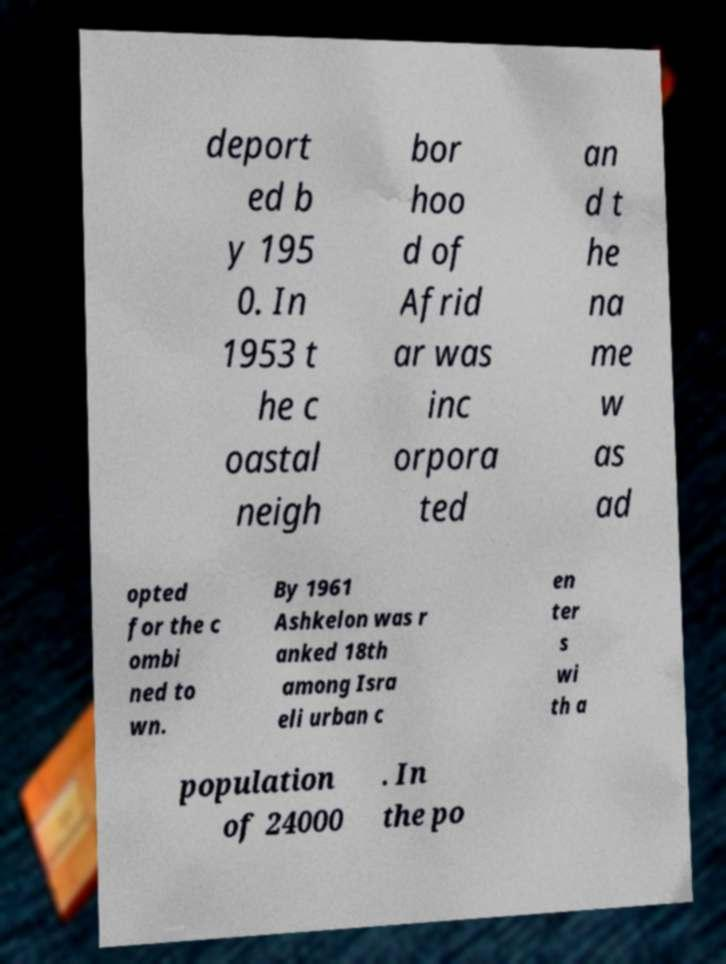I need the written content from this picture converted into text. Can you do that? deport ed b y 195 0. In 1953 t he c oastal neigh bor hoo d of Afrid ar was inc orpora ted an d t he na me w as ad opted for the c ombi ned to wn. By 1961 Ashkelon was r anked 18th among Isra eli urban c en ter s wi th a population of 24000 . In the po 